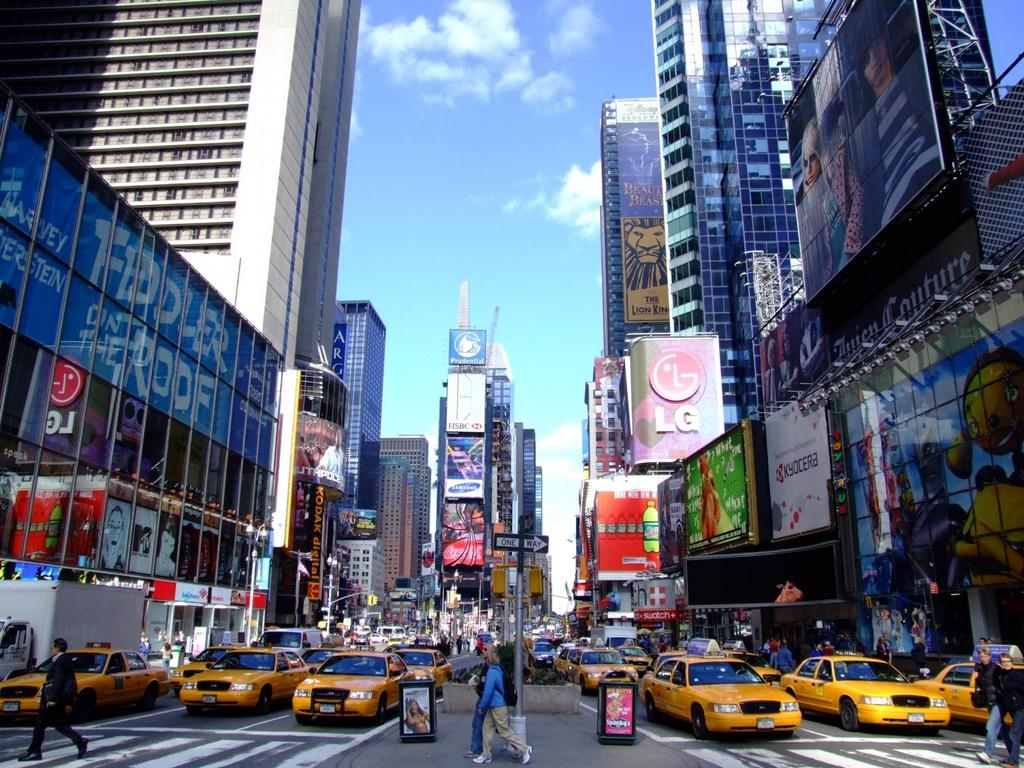<image>
Describe the image concisely. An advertisement for Lion King is on skyscraper in a busy city. 